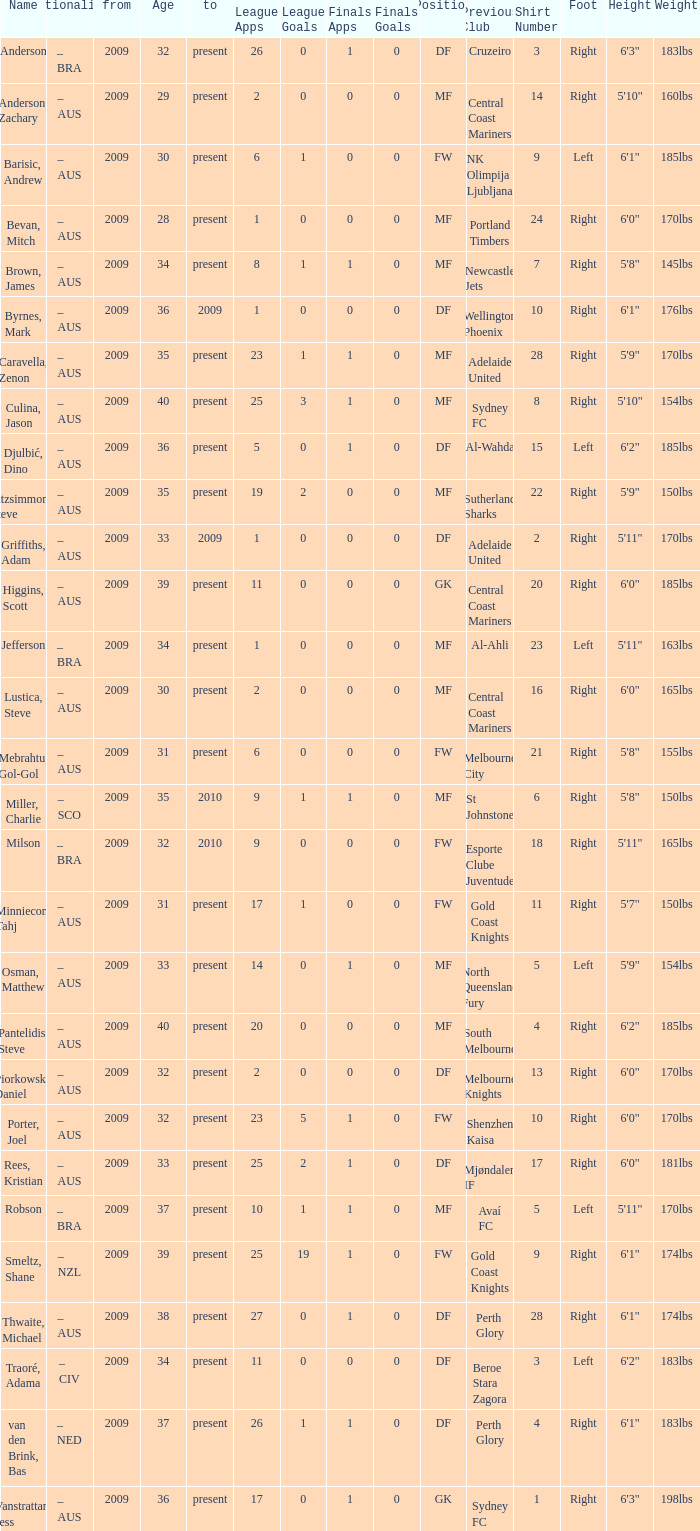Name the to for 19 league apps Present. 